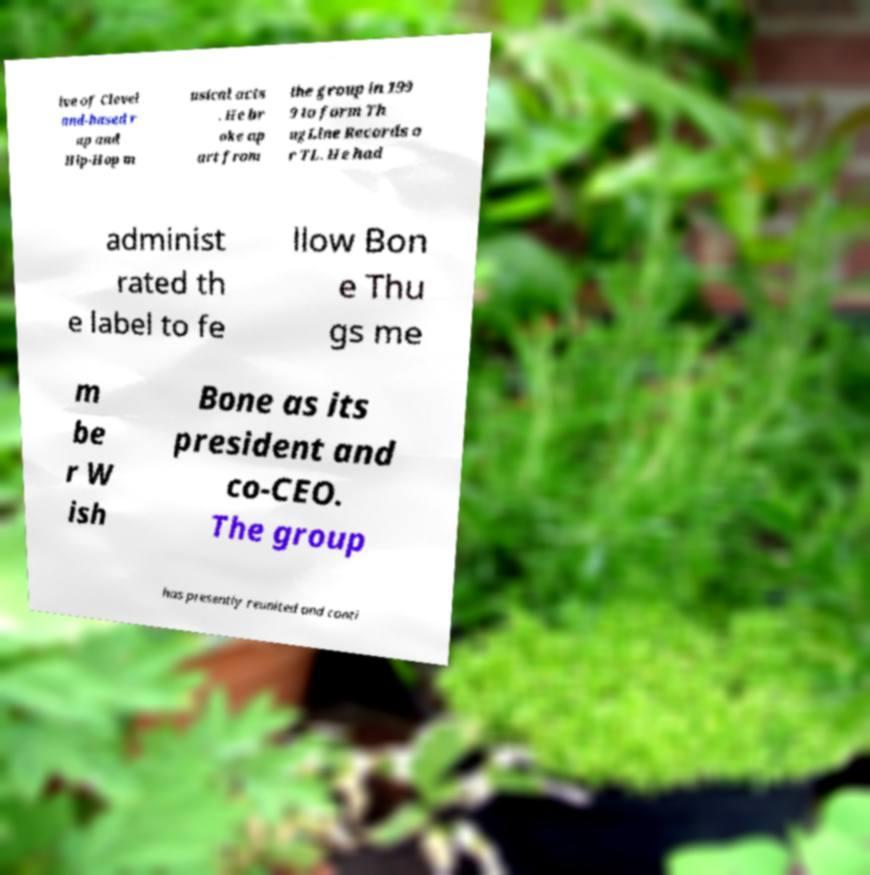What messages or text are displayed in this image? I need them in a readable, typed format. ive of Clevel and-based r ap and Hip-Hop m usical acts . He br oke ap art from the group in 199 9 to form Th ugLine Records o r TL. He had administ rated th e label to fe llow Bon e Thu gs me m be r W ish Bone as its president and co-CEO. The group has presently reunited and conti 